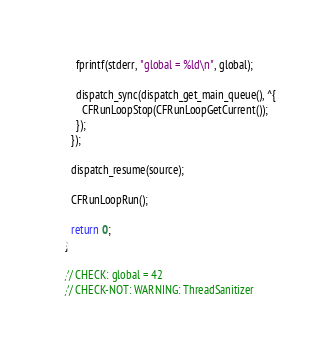<code> <loc_0><loc_0><loc_500><loc_500><_ObjectiveC_>    fprintf(stderr, "global = %ld\n", global);

    dispatch_sync(dispatch_get_main_queue(), ^{
      CFRunLoopStop(CFRunLoopGetCurrent());
    });
  });

  dispatch_resume(source);

  CFRunLoopRun();

  return 0;
}

// CHECK: global = 42
// CHECK-NOT: WARNING: ThreadSanitizer
</code> 